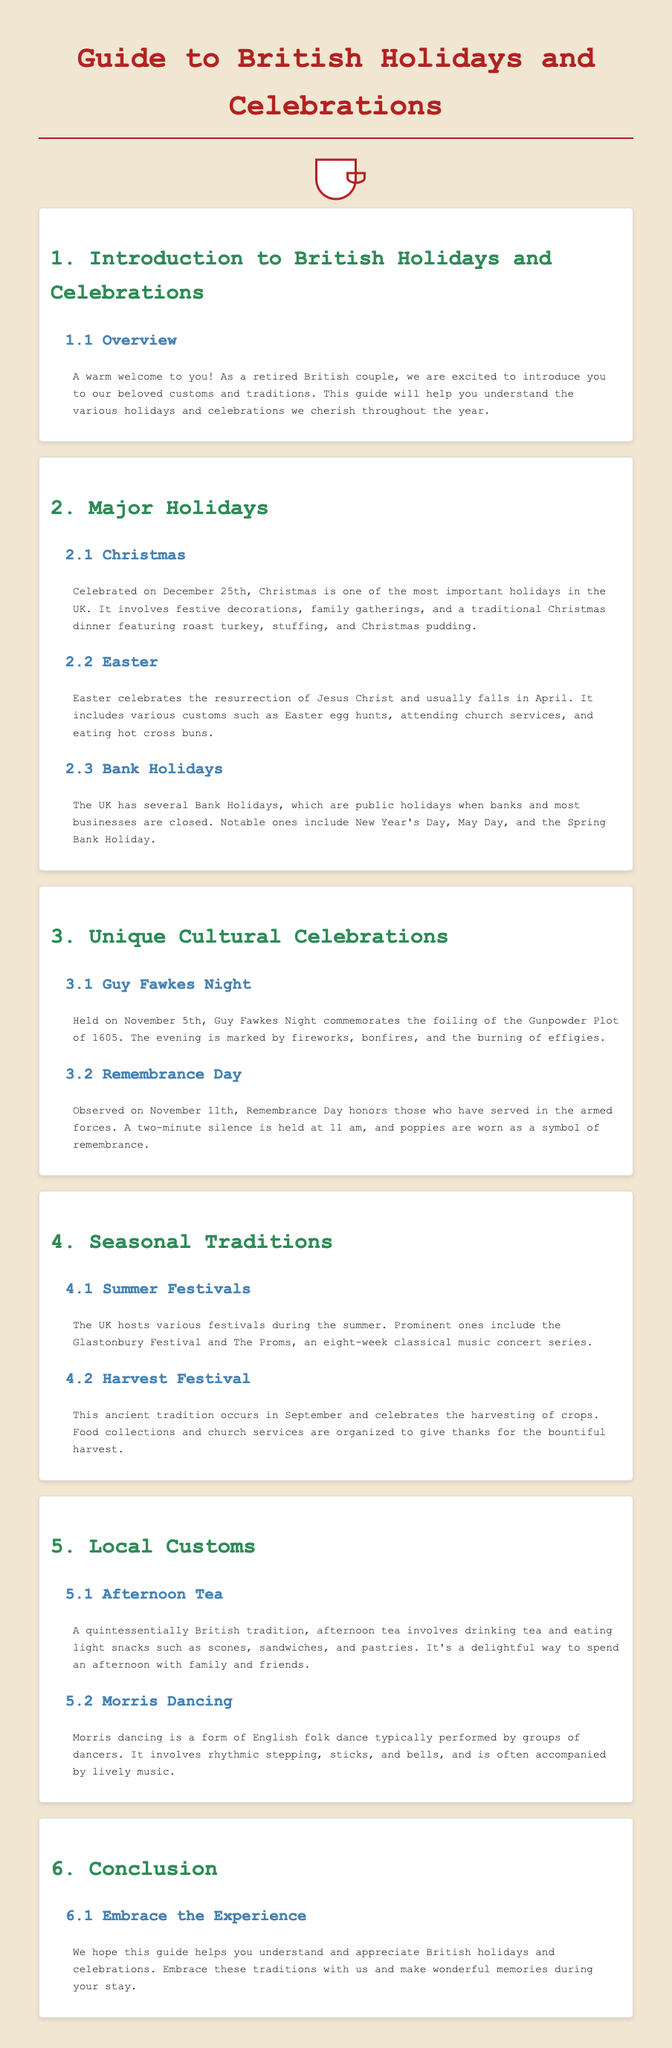What is the first holiday mentioned in the guide? The first holiday mentioned is Christmas, which falls on December 25th.
Answer: Christmas What date is Guy Fawkes Night celebrated? Guy Fawkes Night is celebrated on November 5th.
Answer: November 5th What type of food is typically served during Christmas dinner? The traditional Christmas dinner features roast turkey, stuffing, and Christmas pudding.
Answer: Roast turkey, stuffing, and Christmas pudding What notable public holiday falls in May? One of the notable Bank Holidays in May is May Day.
Answer: May Day What symbol is worn on Remembrance Day? On Remembrance Day, poppies are worn as a symbol of remembrance.
Answer: Poppies How long does The Proms concert series last? The Proms is an eight-week classical music concert series.
Answer: Eight weeks What is a quintessentially British tradition involving tea? Afternoon tea involves drinking tea and eating light snacks.
Answer: Afternoon tea What is the purpose of the Harvest Festival? The Harvest Festival celebrates the harvesting of crops and gives thanks for the bountiful harvest.
Answer: Celebrating the harvesting of crops What is Morris dancing characterized by? Morris dancing is characterized by rhythmic stepping, sticks, and bells.
Answer: Rhythmic stepping, sticks, and bells 